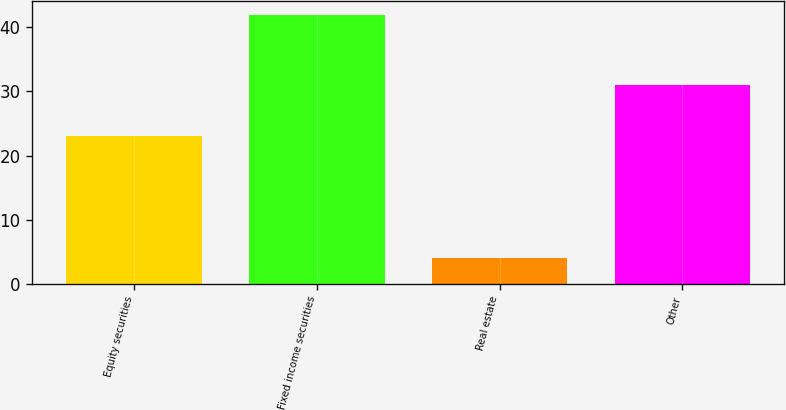Convert chart. <chart><loc_0><loc_0><loc_500><loc_500><bar_chart><fcel>Equity securities<fcel>Fixed income securities<fcel>Real estate<fcel>Other<nl><fcel>23<fcel>42<fcel>4<fcel>31<nl></chart> 